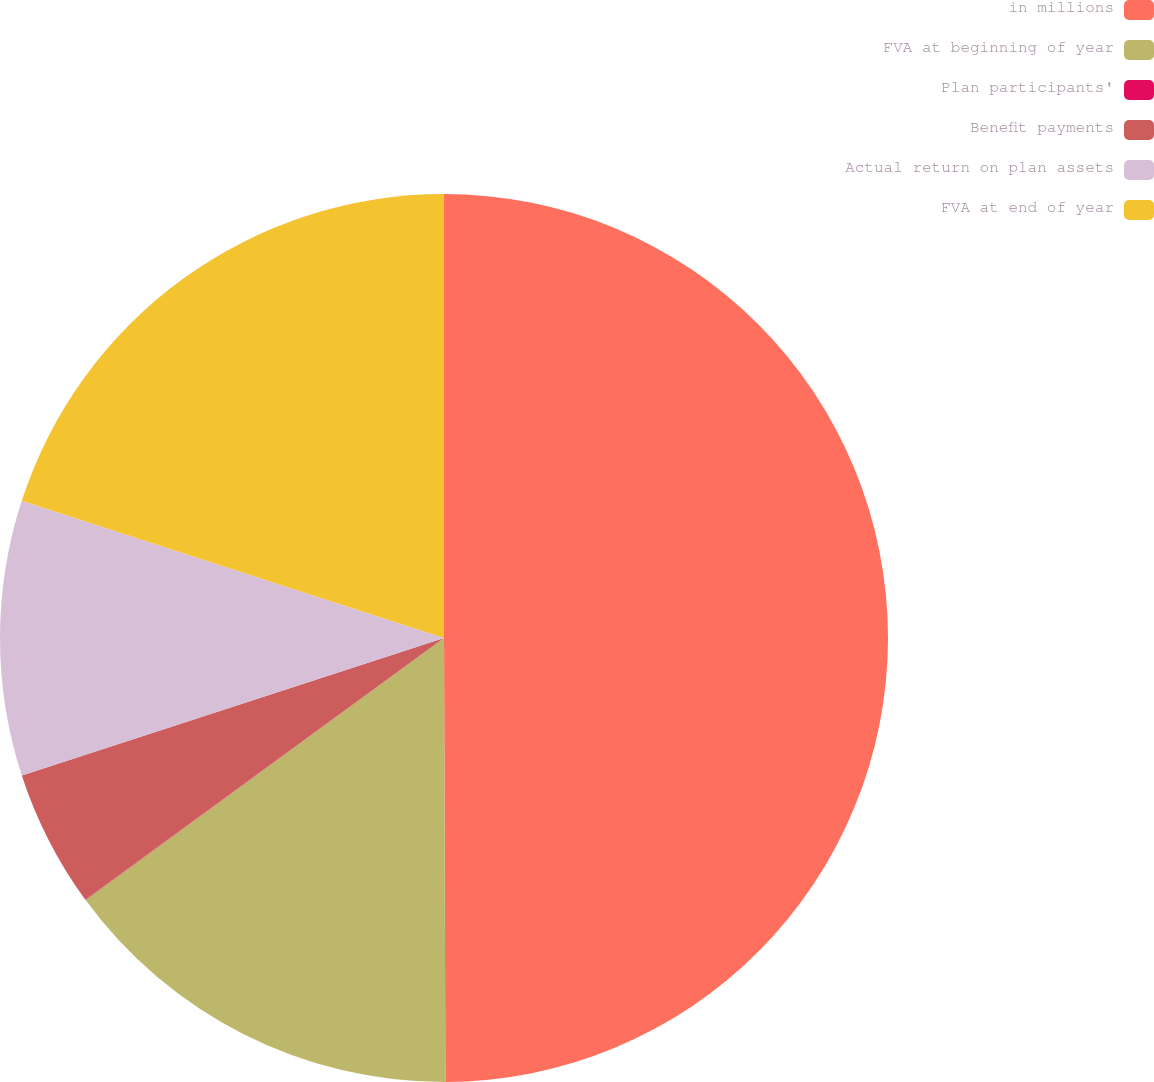<chart> <loc_0><loc_0><loc_500><loc_500><pie_chart><fcel>in millions<fcel>FVA at beginning of year<fcel>Plan participants'<fcel>Benefit payments<fcel>Actual return on plan assets<fcel>FVA at end of year<nl><fcel>49.95%<fcel>15.0%<fcel>0.02%<fcel>5.02%<fcel>10.01%<fcel>20.0%<nl></chart> 